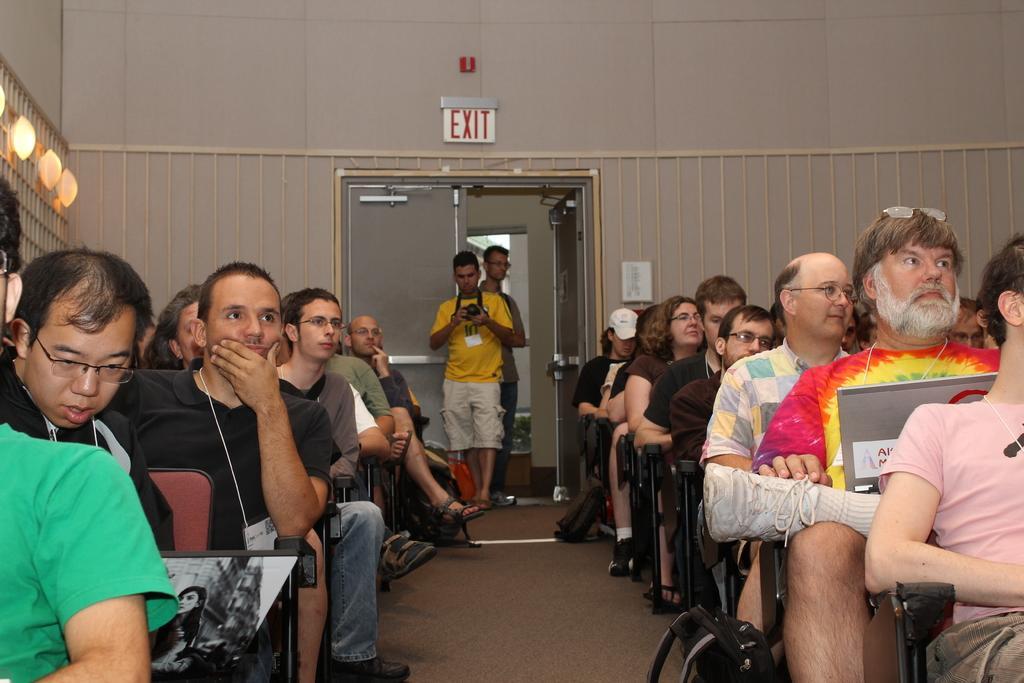Can you describe this image briefly? This picture is taken inside the room. In this image, on the right side, we can see a group of people sitting on the chair. On the right side, we can also see a bag. On the left side, we can also see a group of people sitting on the chair. In the background, we can see a man wearing yellow color shirt standing and holding a camera in his hand. In the background, we can also see a another person. In the background, we can see doors. On the left side, we can see few lights. 